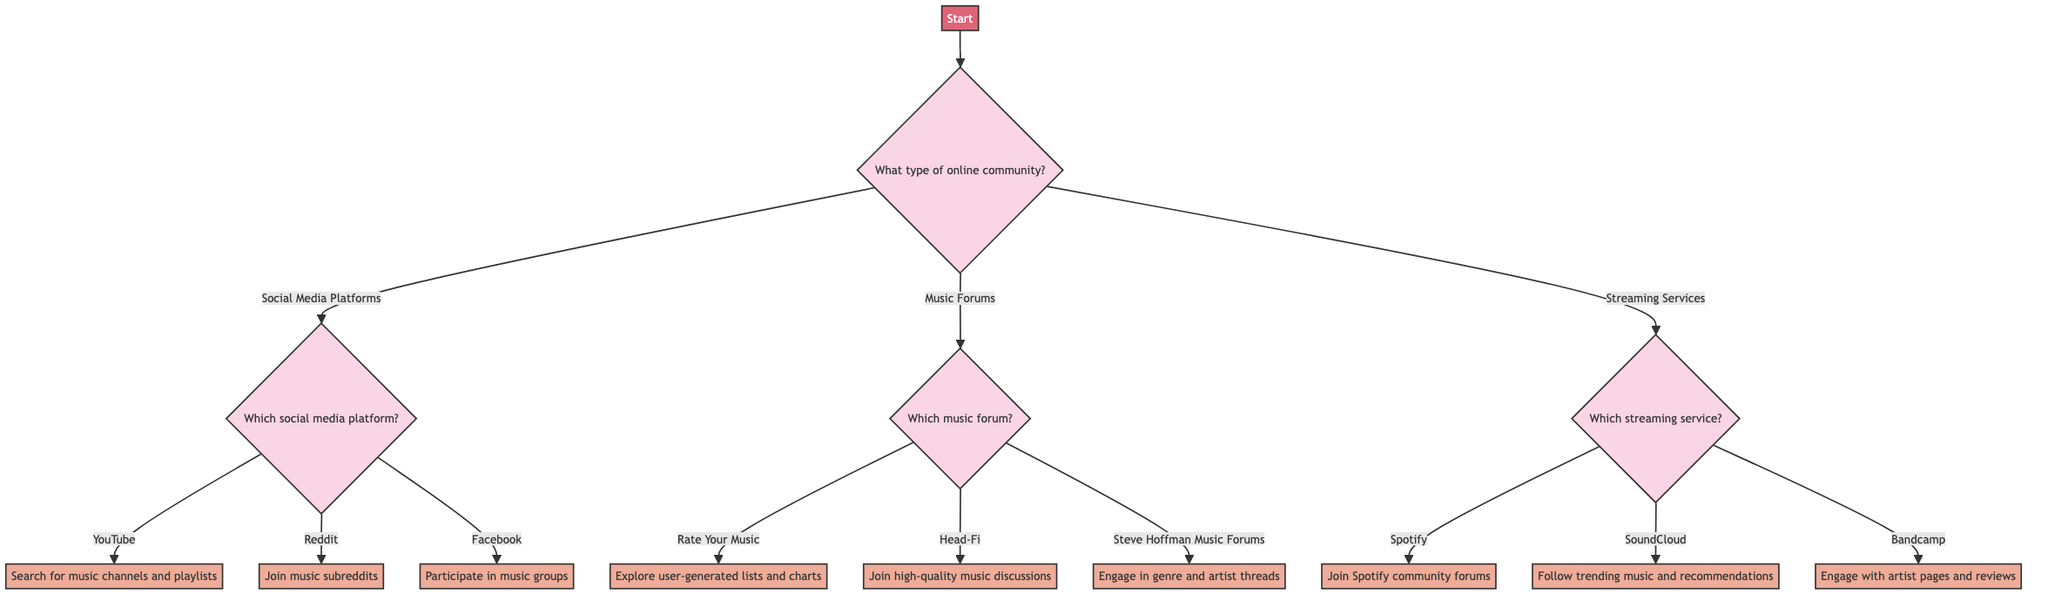What type of online community is the starting point? The diagram starts with a node labeled "Start," which branches into three main options: "Social Media Platforms," "Music Forums," and "Streaming Services."
Answer: Social Media Platforms, Music Forums, Streaming Services How many options are provided under the "Social Media Platforms" category? The "Social Media Platforms" category has three options listed: YouTube, Reddit, and Facebook. Therefore, counting these, we find there are three options.
Answer: 3 What specific action is suggested for the Reddit option? Under the Reddit option, the action suggested is to "Join subreddits such as r/listentothis, r/ifyoulikeblank, and r/indieheads." This constitutes the output that connects the choice to the recommended action.
Answer: Join subreddits such as r/listentothis, r/ifyoulikeblank, and r/indieheads If you choose "Music Forums" and then "Steve Hoffman Music Forums," what action should you take? Selecting "Music Forums" leads to a choice of three forums; once "Steve Hoffman Music Forums" is selected, the recommended action is to "Engage with users in threads dedicated to different genres, new releases, and artist discussions." This provides the guidance from the specific pathway chosen.
Answer: Engage with users in threads dedicated to different genres, new releases, and artist discussions What action is recommended for the Spotify option? Following the decision tree from the beginning to select "Streaming Services," then "Spotify," the action recommended is to "Join Spotify community forums, explore user-curated playlists, and follow Discover Weekly and Release Radar playlists." This answer reflects what to do after following that path.
Answer: Join Spotify community forums, explore user-curated playlists, and follow Discover Weekly and Release Radar playlists What are the total number of nodes under the "Streaming Services" category? The "Streaming Services" category includes three distinct options: Spotify, SoundCloud, and Bandcamp. Each of these counts as a node, resulting in a total of three nodes under this category.
Answer: 3 Which music forum allows discussions on high-quality music? Among the options under "Music Forums," the node for "Head-Fi" is specifically aimed at discussions about high-quality music, as stated directly in the corresponding action.
Answer: Head-Fi How many main categories are there in the decision tree? The diagram branches out from the starting point into three main categories: Social Media Platforms, Music Forums, and Streaming Services. Thus, there are three main categories represented in the decision tree.
Answer: 3 